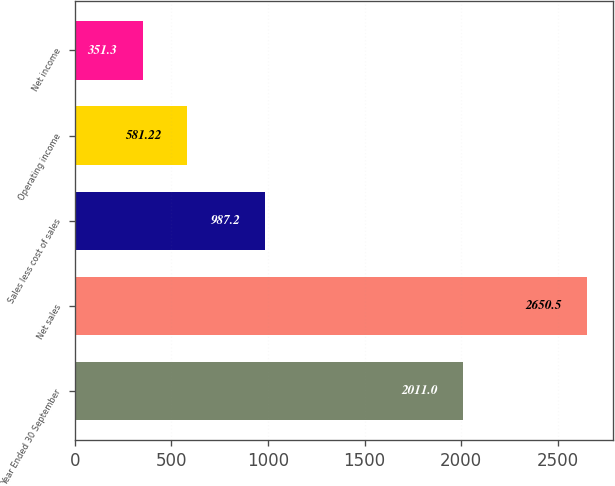<chart> <loc_0><loc_0><loc_500><loc_500><bar_chart><fcel>Year Ended 30 September<fcel>Net sales<fcel>Sales less cost of sales<fcel>Operating income<fcel>Net income<nl><fcel>2011<fcel>2650.5<fcel>987.2<fcel>581.22<fcel>351.3<nl></chart> 